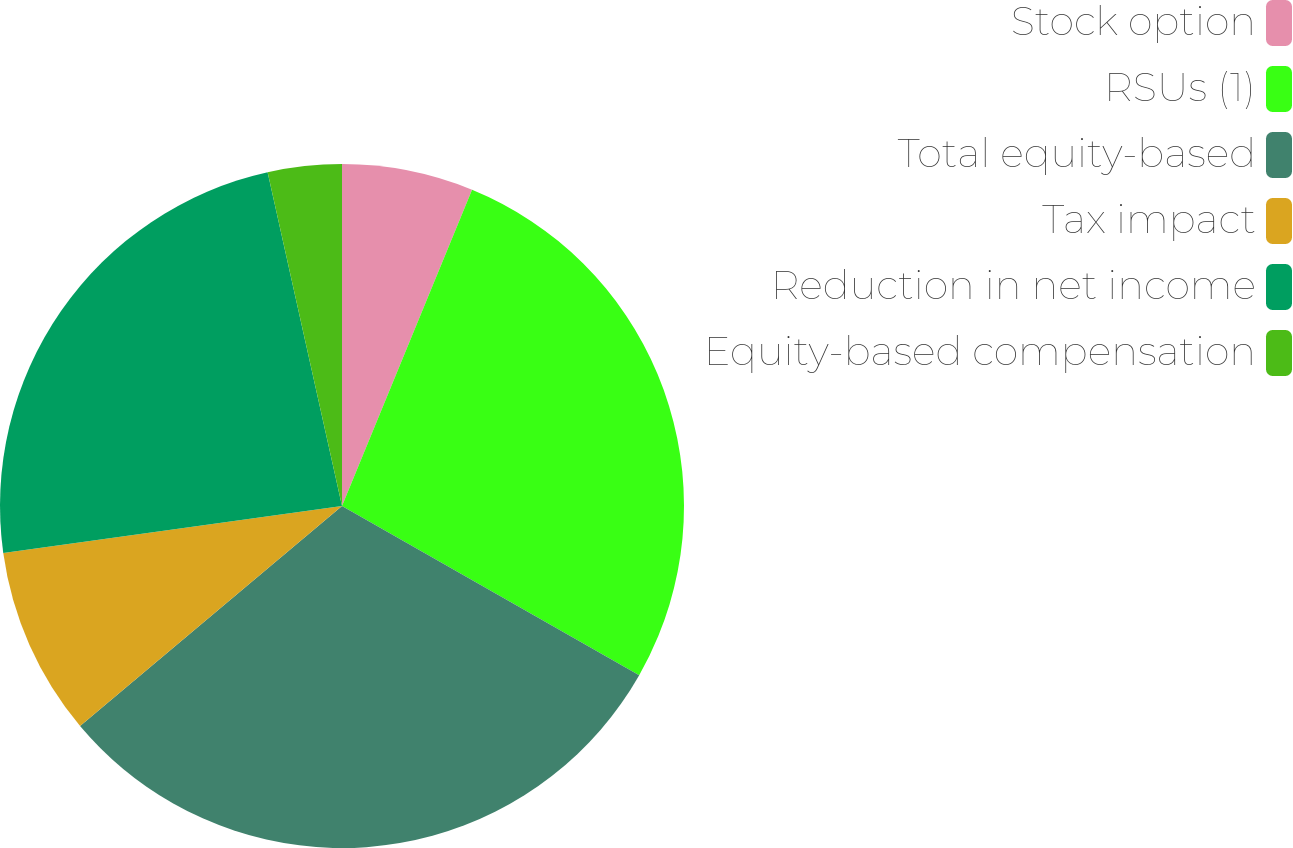Convert chart. <chart><loc_0><loc_0><loc_500><loc_500><pie_chart><fcel>Stock option<fcel>RSUs (1)<fcel>Total equity-based<fcel>Tax impact<fcel>Reduction in net income<fcel>Equity-based compensation<nl><fcel>6.21%<fcel>27.03%<fcel>30.65%<fcel>8.92%<fcel>23.71%<fcel>3.49%<nl></chart> 